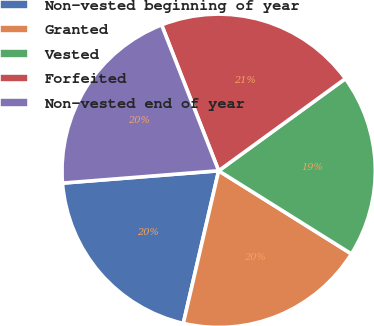Convert chart to OTSL. <chart><loc_0><loc_0><loc_500><loc_500><pie_chart><fcel>Non-vested beginning of year<fcel>Granted<fcel>Vested<fcel>Forfeited<fcel>Non-vested end of year<nl><fcel>20.12%<fcel>19.72%<fcel>18.91%<fcel>20.93%<fcel>20.32%<nl></chart> 